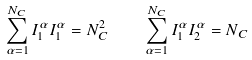Convert formula to latex. <formula><loc_0><loc_0><loc_500><loc_500>\sum _ { \alpha = 1 } ^ { N _ { C } } I _ { 1 } ^ { \alpha } I _ { 1 } ^ { \alpha } = N _ { C } ^ { 2 } \quad \sum _ { \alpha = 1 } ^ { N _ { C } } I _ { 1 } ^ { \alpha } I _ { 2 } ^ { \alpha } = N _ { C }</formula> 